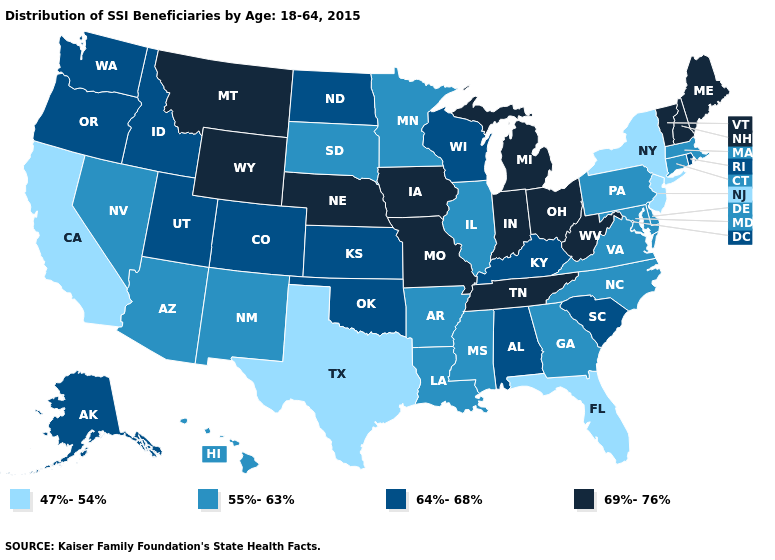Among the states that border Idaho , does Montana have the highest value?
Quick response, please. Yes. Name the states that have a value in the range 55%-63%?
Quick response, please. Arizona, Arkansas, Connecticut, Delaware, Georgia, Hawaii, Illinois, Louisiana, Maryland, Massachusetts, Minnesota, Mississippi, Nevada, New Mexico, North Carolina, Pennsylvania, South Dakota, Virginia. Which states have the lowest value in the USA?
Keep it brief. California, Florida, New Jersey, New York, Texas. What is the highest value in the USA?
Give a very brief answer. 69%-76%. What is the value of Virginia?
Write a very short answer. 55%-63%. What is the value of Utah?
Answer briefly. 64%-68%. What is the lowest value in the West?
Give a very brief answer. 47%-54%. Name the states that have a value in the range 69%-76%?
Write a very short answer. Indiana, Iowa, Maine, Michigan, Missouri, Montana, Nebraska, New Hampshire, Ohio, Tennessee, Vermont, West Virginia, Wyoming. Does the first symbol in the legend represent the smallest category?
Write a very short answer. Yes. Name the states that have a value in the range 69%-76%?
Quick response, please. Indiana, Iowa, Maine, Michigan, Missouri, Montana, Nebraska, New Hampshire, Ohio, Tennessee, Vermont, West Virginia, Wyoming. Name the states that have a value in the range 64%-68%?
Quick response, please. Alabama, Alaska, Colorado, Idaho, Kansas, Kentucky, North Dakota, Oklahoma, Oregon, Rhode Island, South Carolina, Utah, Washington, Wisconsin. How many symbols are there in the legend?
Answer briefly. 4. Name the states that have a value in the range 64%-68%?
Give a very brief answer. Alabama, Alaska, Colorado, Idaho, Kansas, Kentucky, North Dakota, Oklahoma, Oregon, Rhode Island, South Carolina, Utah, Washington, Wisconsin. Does Alabama have the same value as Washington?
Write a very short answer. Yes. 